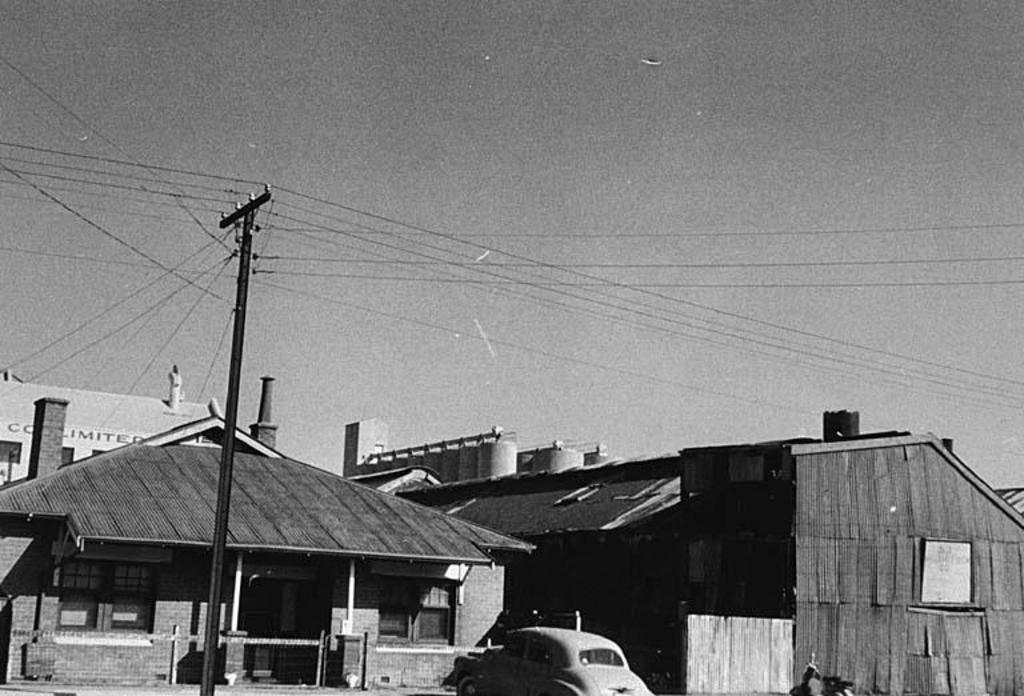What structures are located at the bottom of the image? There are sheds and a car at the bottom of the image. What can be seen on the left side of the image? There is a pole on the left side of the image. What is present at the top of the image? There are wires and the sky visible at the top of the image. What type of watch can be seen on the pole in the image? There is no watch present in the image; the pole is not associated with any timekeeping device. 